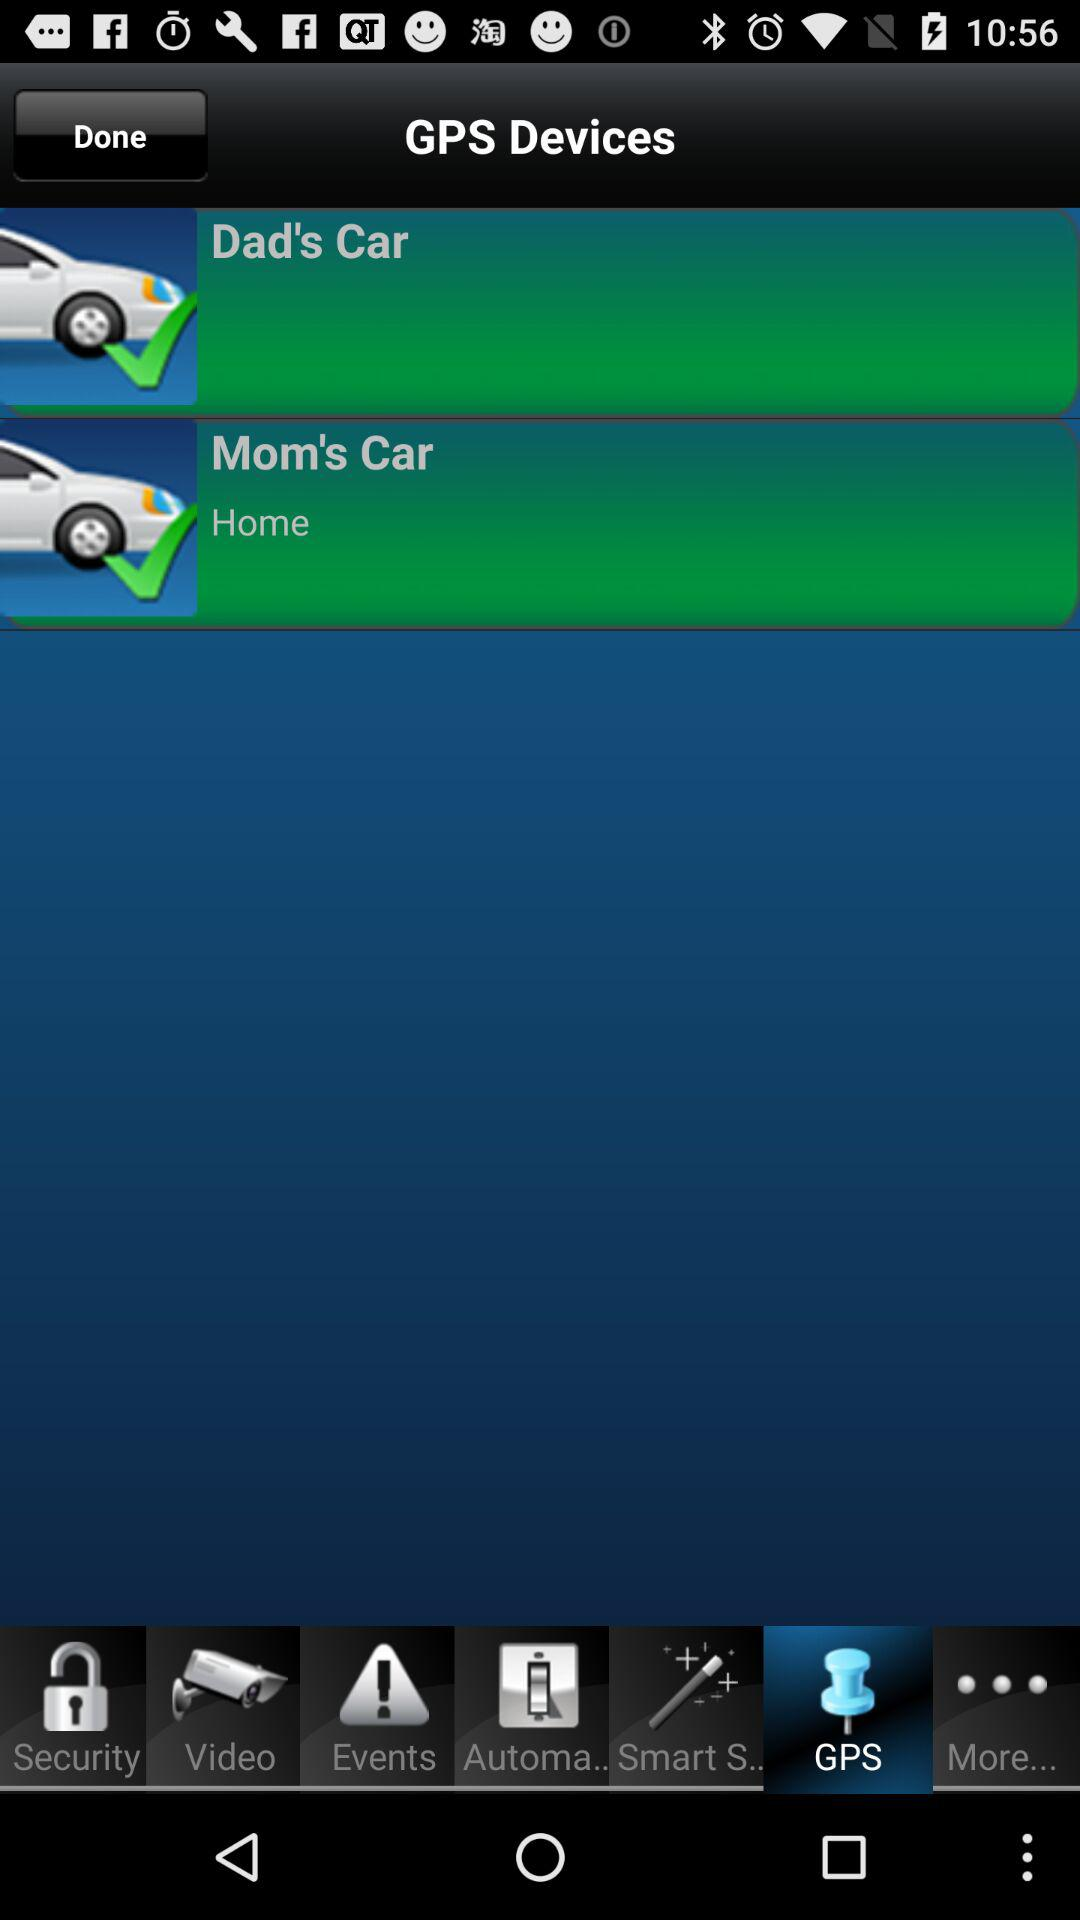Where is mom's car? Mom's car is at home. 